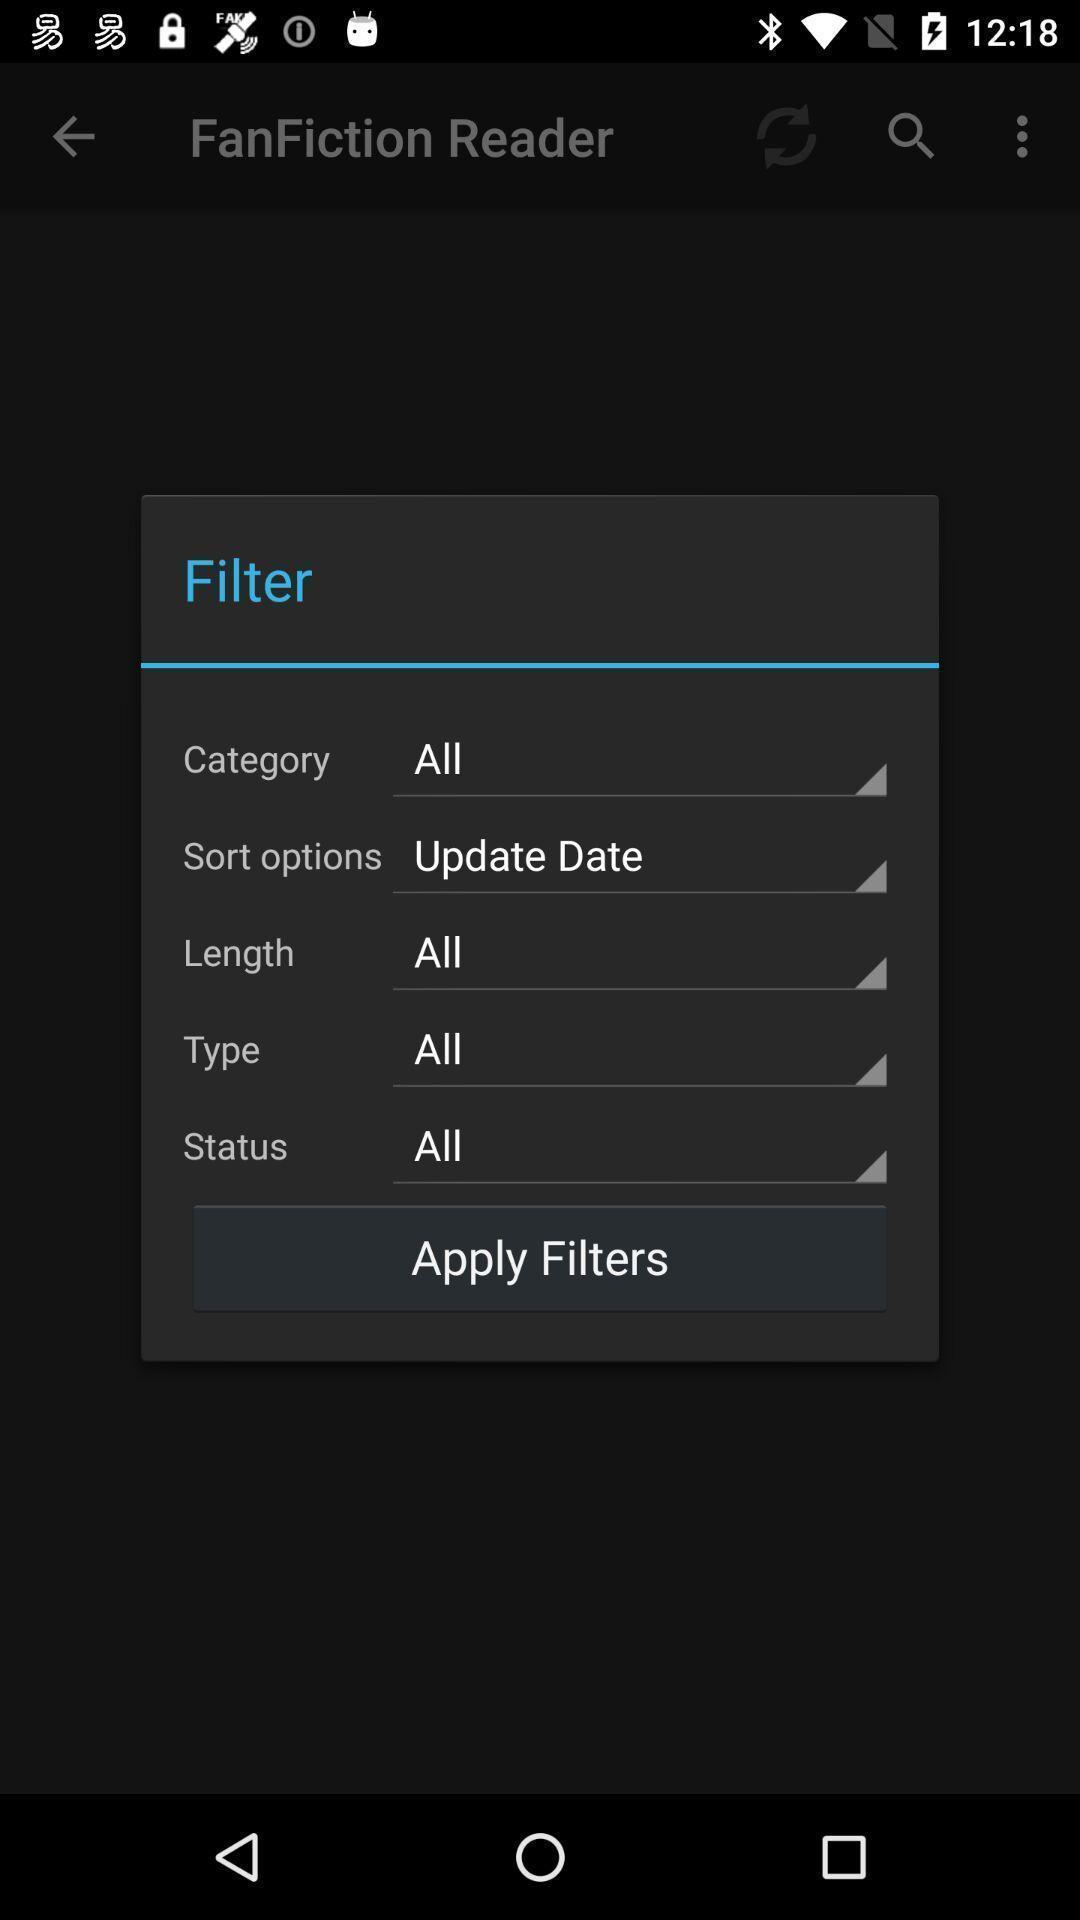Give me a narrative description of this picture. Pop-up is showing different parameters for applying filters. 